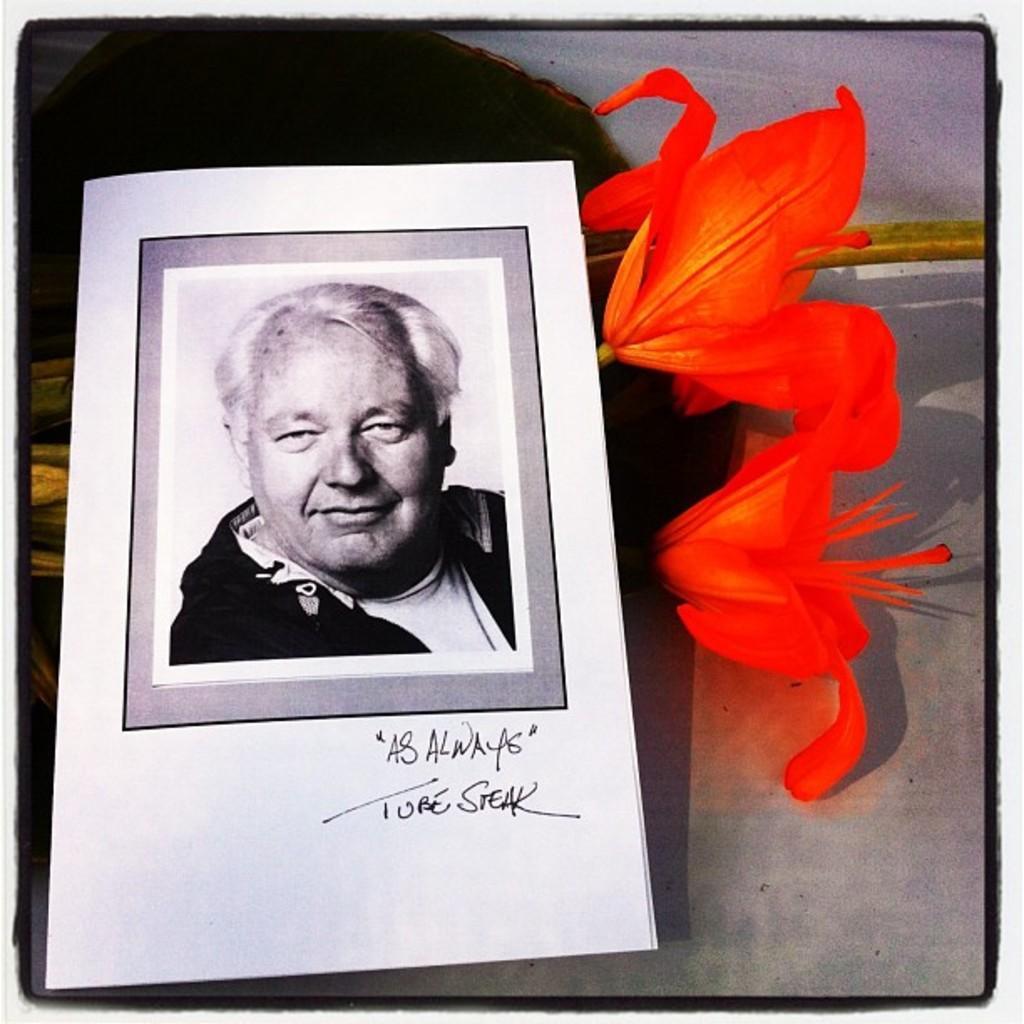Describe this image in one or two sentences. In this picture we can see a paper and few flowers, in the paper we can find a man. 